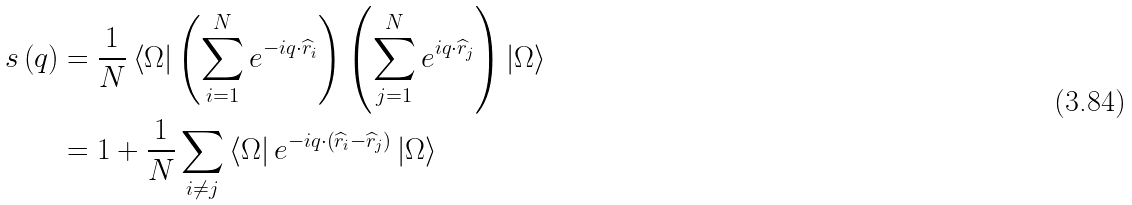Convert formula to latex. <formula><loc_0><loc_0><loc_500><loc_500>s \left ( q \right ) & = \frac { 1 } { N } \left \langle \Omega \right | \left ( \sum _ { i = 1 } ^ { N } e ^ { - i q \cdot \widehat { r } _ { i } } \right ) \left ( \sum _ { j = 1 } ^ { N } e ^ { i q \cdot \widehat { r } _ { j } } \right ) \left | \Omega \right \rangle \\ & = 1 + \frac { 1 } { N } \sum _ { i \neq j } \left \langle \Omega \right | e ^ { - i q \cdot \left ( \widehat { r } _ { i } - \widehat { r } _ { j } \right ) } \left | \Omega \right \rangle</formula> 